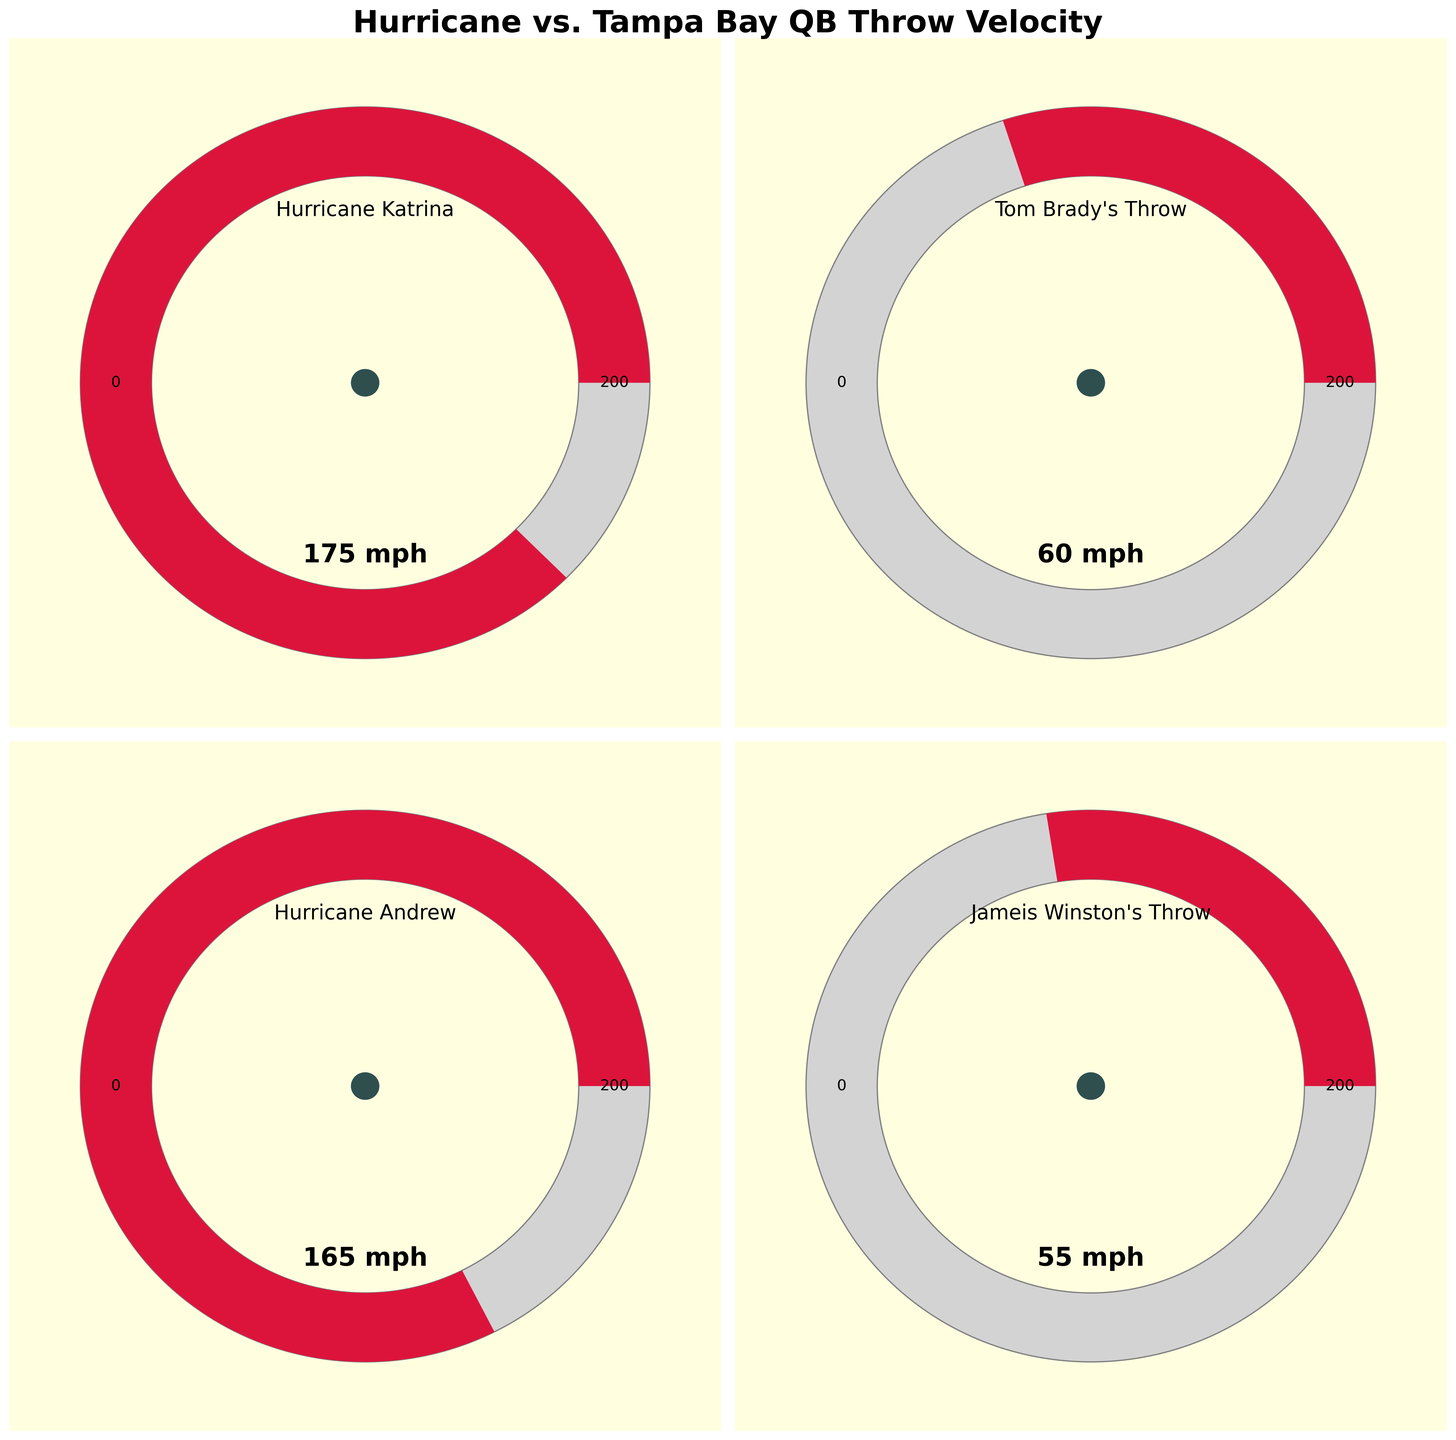What's the title of the figure? The title is usually placed at the top center of the figure, and in this case, it's clearly written in bold.
Answer: Hurricane vs. Tampa Bay QB Throw Velocity How many data points are presented in the figure? By counting the number of separate gauge charts, you can see that there are a total of 8 data points (four hurricanes and four quarterback throws).
Answer: 8 What is the maximum wind speed indicated on the gauges? The maximum wind speed is shown at the top right edge of each gauge chart, with the value labeled as 200 mph.
Answer: 200 mph Which hurricane has the highest wind speed in the figure? By looking at the gauge charts, you can see that Hurricane Katrina's gauge is filled the most, indicating a value of 175 mph.
Answer: Hurricane Katrina Which two quarterbacks have the closest throw velocities? By comparing the gauge charts for the quarterbacks, Jameis Winston's Throw (55 mph) and Kyle Trask's Throw (52 mph) are the closest in value.
Answer: Jameis Winston and Kyle Trask How much faster is Hurricane Michael compared to Kyle Trask's throw? Hurricane Michael has a wind speed of 160 mph, and Kyle Trask's throw velocity is 52 mph. Subtract 52 from 160 to find the difference. 160 - 52 = 108 mph.
Answer: 108 mph What is the range of wind speeds among the hurricanes shown? The range is calculated by subtracting the smallest value (Hurricane Ida, 150 mph) from the largest value (Hurricane Katrina, 175 mph). 175 - 150 = 25 mph.
Answer: 25 mph Which category (hurricanes or quarterbacks) generally has higher values on the gauges? By scanning across all the gauge charts, it is clear that hurricanes have higher values compared to quarterback throws.
Answer: Hurricanes What is the average throw velocity of the quarterbacks? Add all the throw values together (60 + 55 + 58 + 52) = 225, then divide by the number of quarterbacks (4). 225 / 4 = 56.25 mph.
Answer: 56.25 mph Is there any gauge where the value reaches or exceeds 90% of the maximum value? 90% of the maximum value (200 mph) is 180 mph. By looking at the gauges, none of the values reach or exceed 180 mph.
Answer: No 